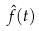Convert formula to latex. <formula><loc_0><loc_0><loc_500><loc_500>\hat { f } ( t )</formula> 